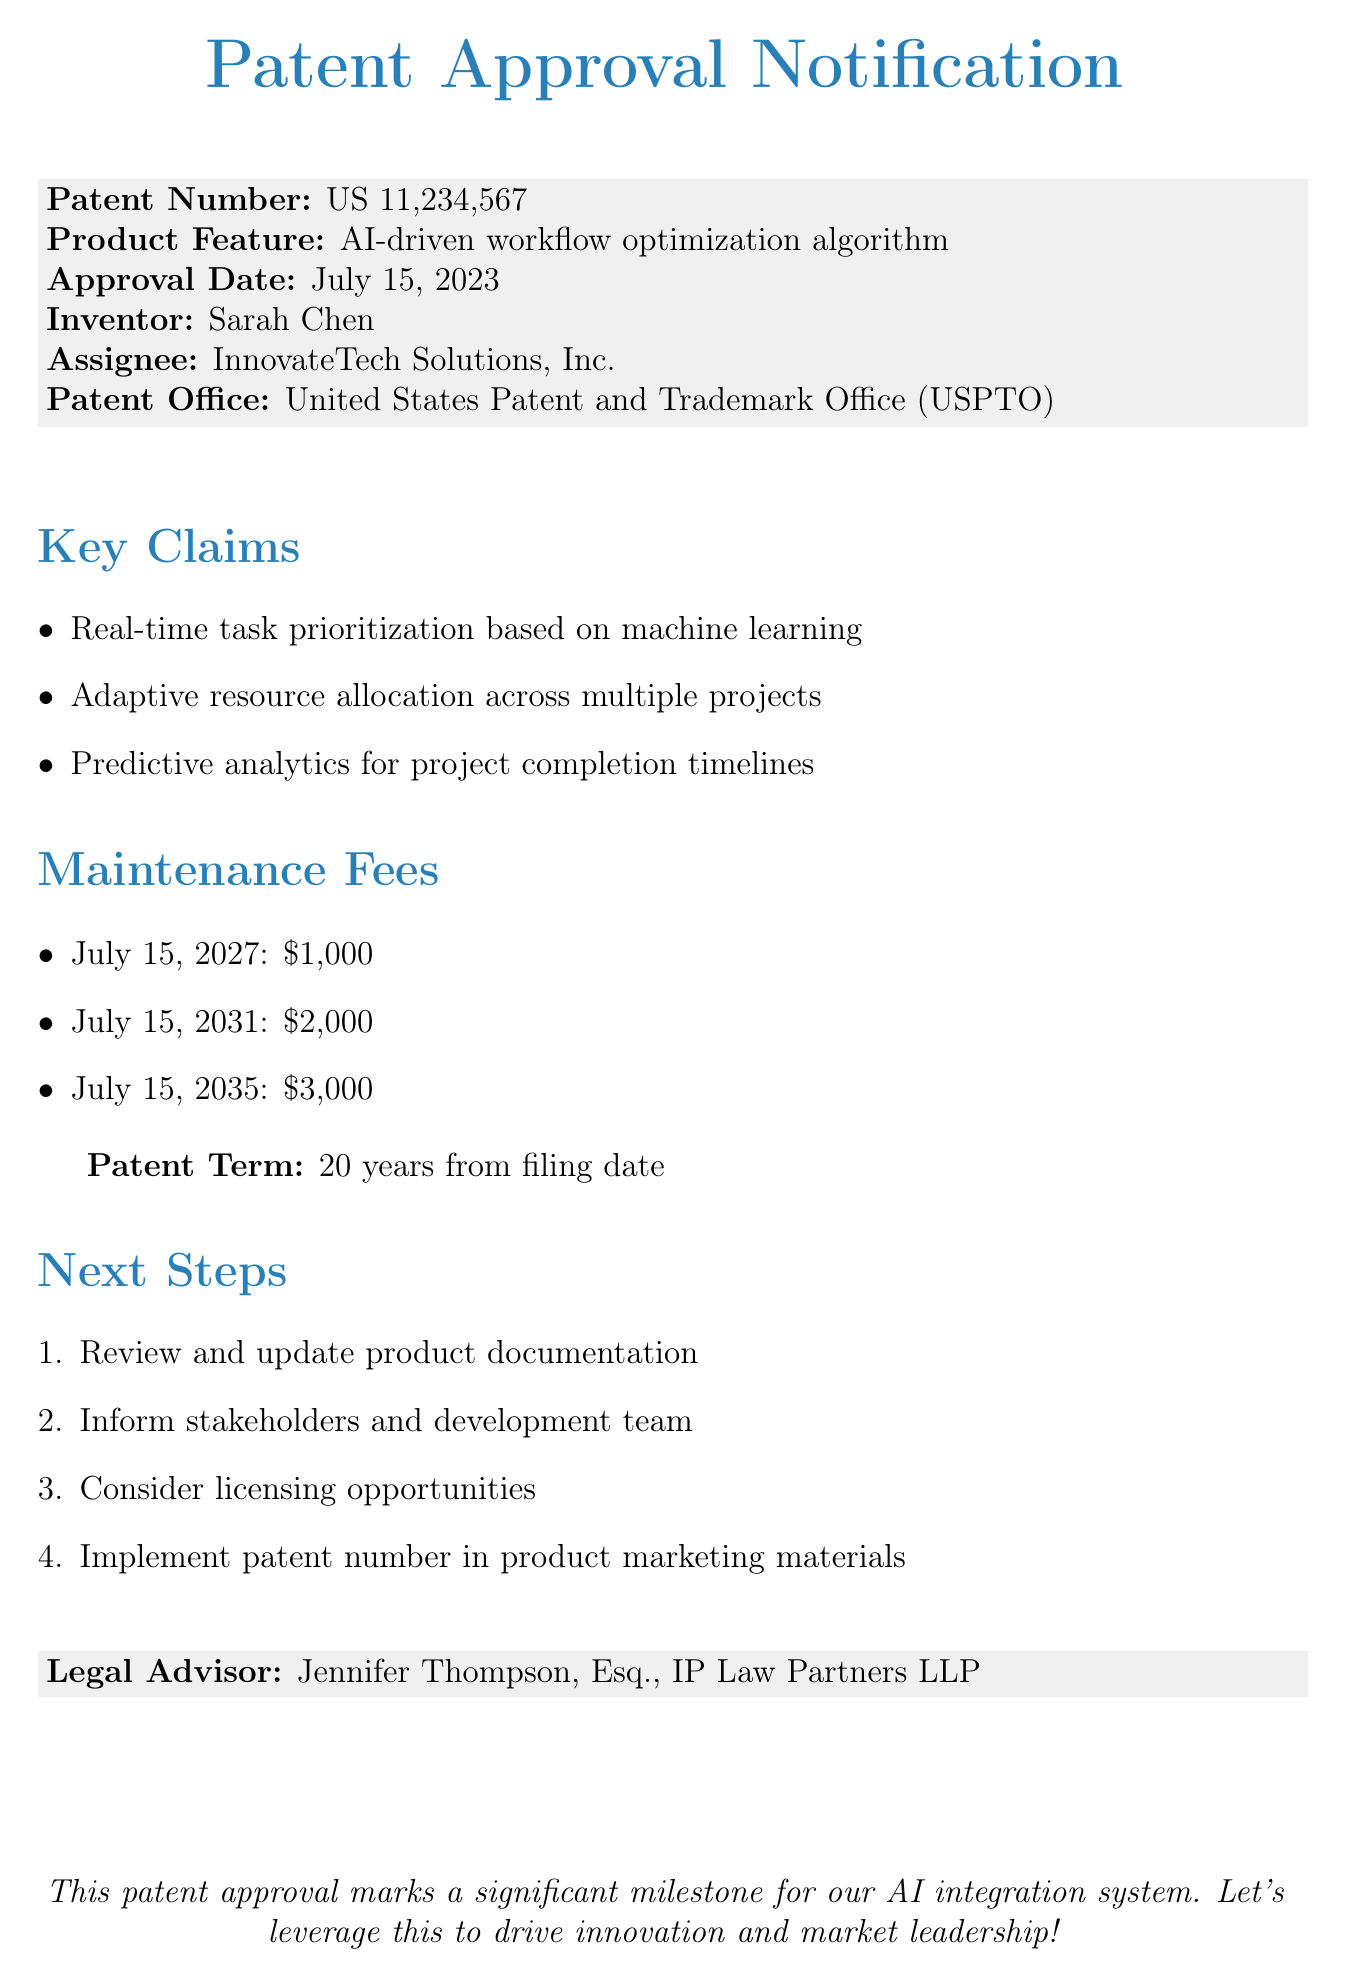What is the patent number? The patent number is explicitly stated in the document under the patent approval notification section.
Answer: US 11,234,567 Who is the inventor of the product feature? The document explicitly mentions the inventor's name in the key details section.
Answer: Sarah Chen What is the amount due for maintenance fees on July 15, 2031? The specific maintenance fee amount for that date is outlined in the maintenance fees section.
Answer: $2,000 When was the patent approved? The approval date is provided clearly in the document under the approval details.
Answer: July 15, 2023 What are the key claims related to the patent? The document lists the key claims in the key claims section.
Answer: Real-time task prioritization based on machine learning, Adaptive resource allocation across multiple projects, Predictive analytics for project completion timelines What are the next steps mentioned in the document? The next steps are listed in a structured manner, clearly defining the required actions post-approval.
Answer: Review and update product documentation, Inform stakeholders and development team, Consider licensing opportunities, Implement patent number in product marketing materials Who is the legal advisor mentioned in the document? The legal advisor's name is provided in the concluding section of the document.
Answer: Jennifer Thompson, Esq., IP Law Partners LLP How long is the patent term? The document states the duration of the patent term under patent information.
Answer: 20 years from filing date 